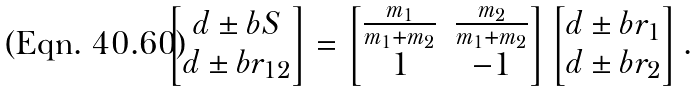<formula> <loc_0><loc_0><loc_500><loc_500>\left [ \begin{matrix} d \pm b { S } \\ d \pm b { r } _ { 1 2 } \end{matrix} \right ] = \left [ \begin{matrix} \frac { m _ { 1 } } { m _ { 1 } + m _ { 2 } } & \frac { m _ { 2 } } { m _ { 1 } + m _ { 2 } } \\ 1 & - 1 \end{matrix} \right ] \left [ \begin{matrix} d \pm b { r } _ { 1 } \\ d \pm b { r } _ { 2 } \end{matrix} \right ] .</formula> 